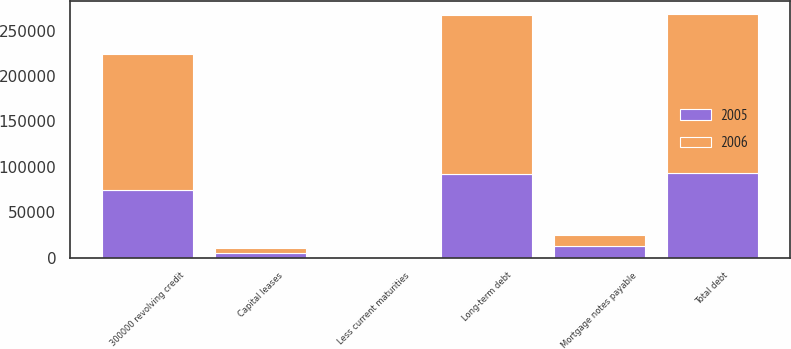<chart> <loc_0><loc_0><loc_500><loc_500><stacked_bar_chart><ecel><fcel>300000 revolving credit<fcel>Mortgage notes payable<fcel>Capital leases<fcel>Total debt<fcel>Less current maturities<fcel>Long-term debt<nl><fcel>2006<fcel>149000<fcel>12487<fcel>5771<fcel>175617<fcel>971<fcel>174646<nl><fcel>2005<fcel>75000<fcel>12974<fcel>5173<fcel>93147<fcel>699<fcel>92448<nl></chart> 